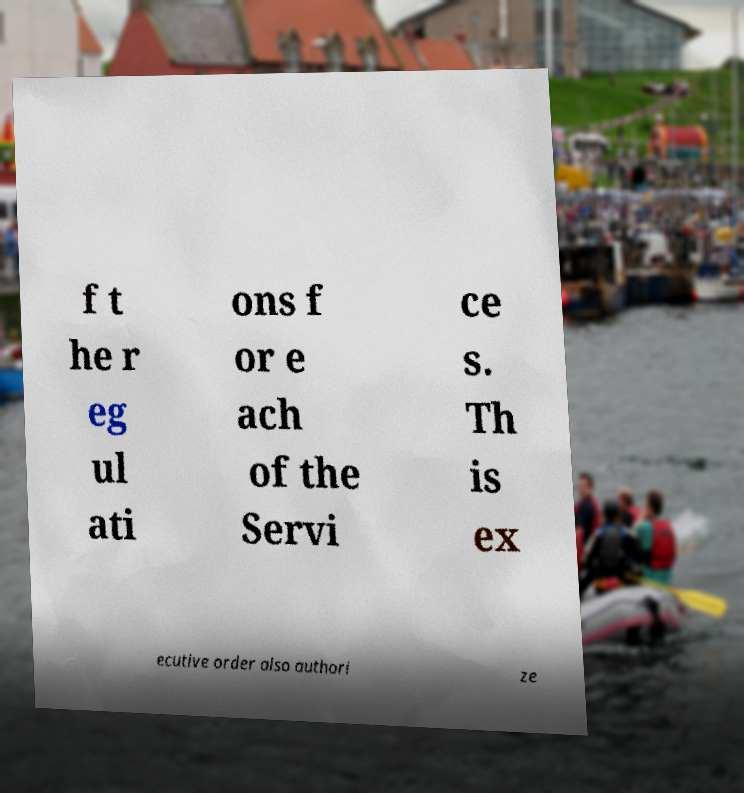Can you accurately transcribe the text from the provided image for me? f t he r eg ul ati ons f or e ach of the Servi ce s. Th is ex ecutive order also authori ze 